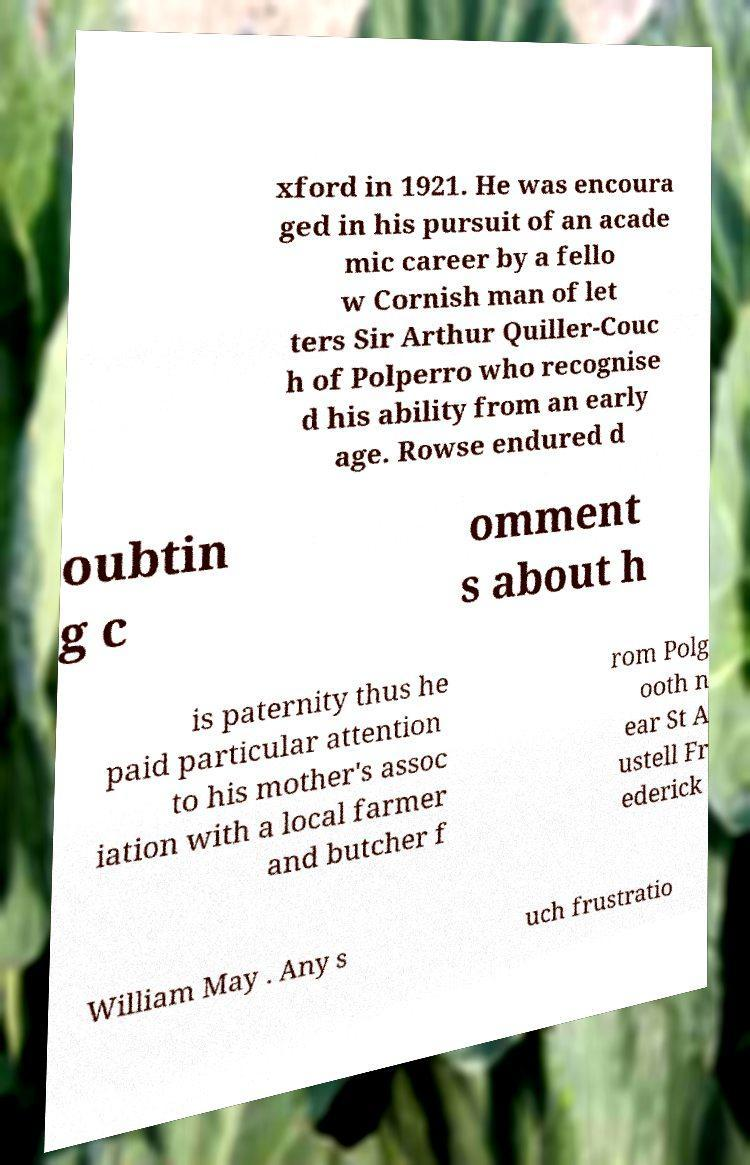Can you accurately transcribe the text from the provided image for me? xford in 1921. He was encoura ged in his pursuit of an acade mic career by a fello w Cornish man of let ters Sir Arthur Quiller-Couc h of Polperro who recognise d his ability from an early age. Rowse endured d oubtin g c omment s about h is paternity thus he paid particular attention to his mother's assoc iation with a local farmer and butcher f rom Polg ooth n ear St A ustell Fr ederick William May . Any s uch frustratio 